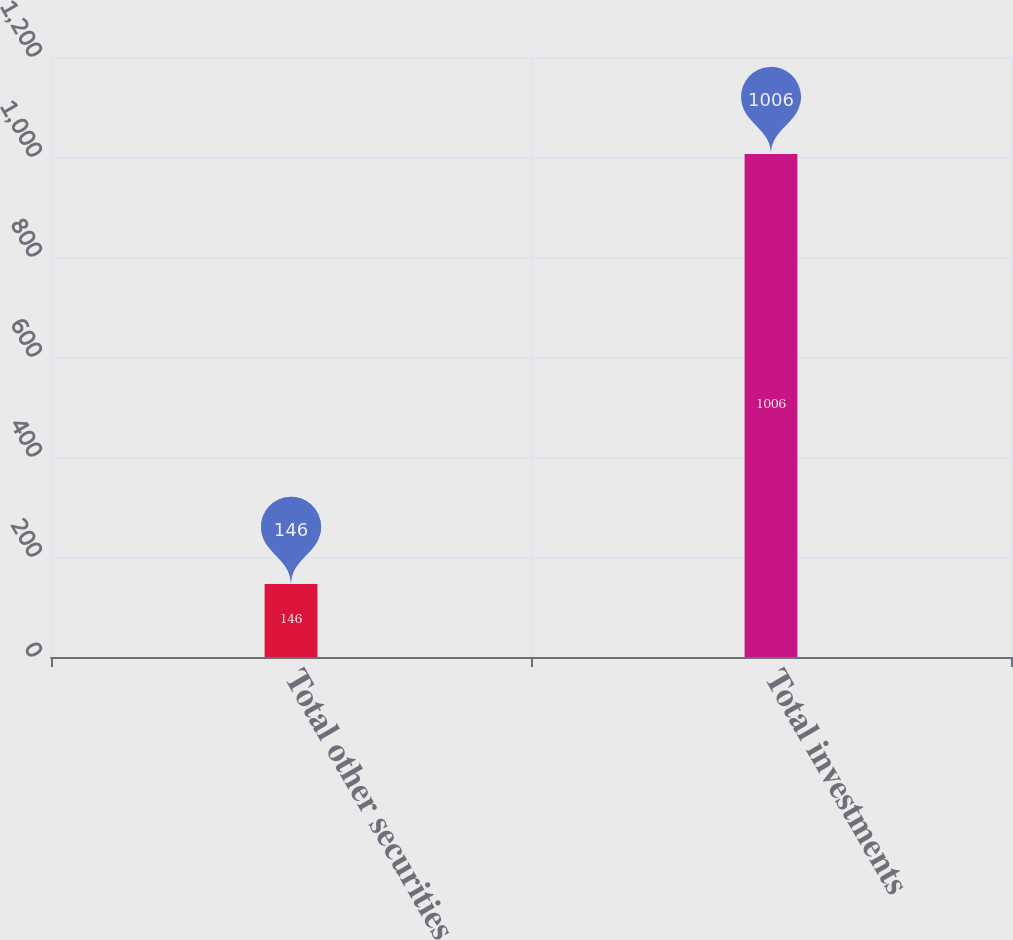Convert chart. <chart><loc_0><loc_0><loc_500><loc_500><bar_chart><fcel>Total other securities<fcel>Total investments<nl><fcel>146<fcel>1006<nl></chart> 